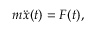Convert formula to latex. <formula><loc_0><loc_0><loc_500><loc_500>m \ddot { x } ( t ) = F ( t ) ,</formula> 